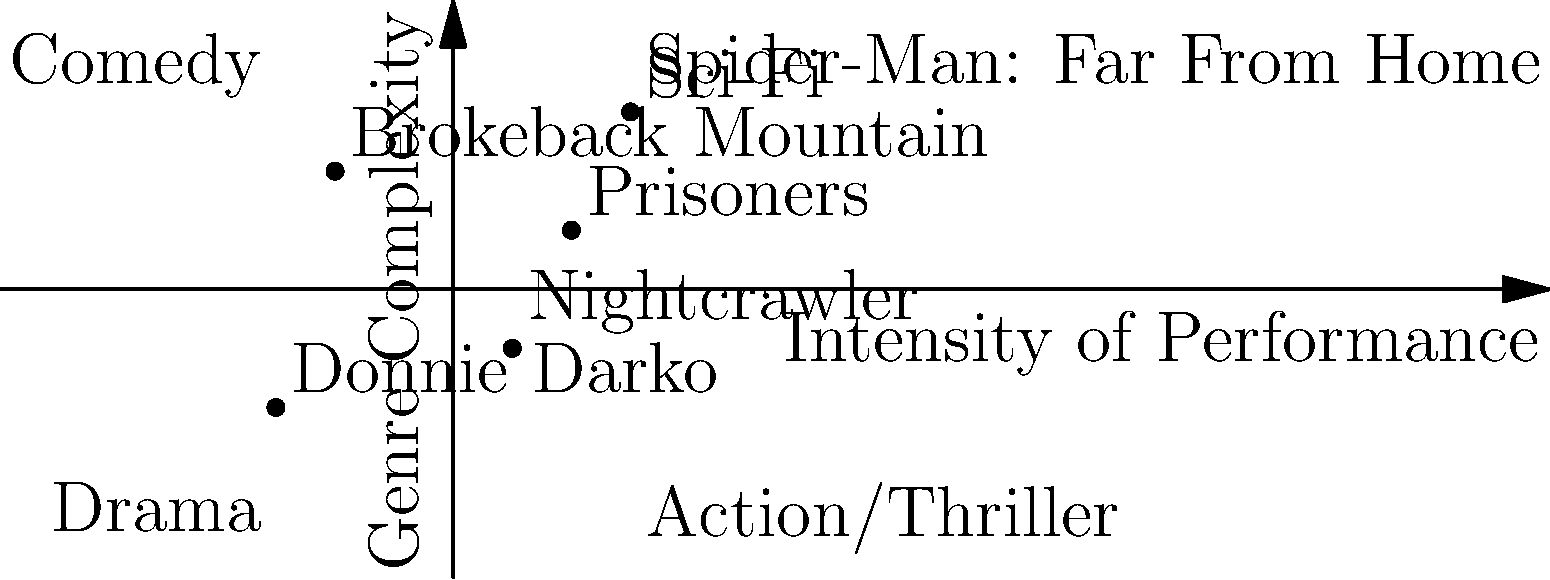In the 2D vector space representing Jake Gyllenhaal's character types, which film represents the highest combination of performance intensity and genre complexity? To determine which film represents the highest combination of performance intensity and genre complexity, we need to analyze the position of each point on the graph:

1. The x-axis represents the intensity of performance, with higher values indicating more intense performances.
2. The y-axis represents genre complexity, with higher values indicating more complex genres.
3. The film that combines the highest values on both axes will be the answer.

Let's examine each point:
1. Donnie Darko: (-3, -2) - Low intensity, low complexity
2. Brokeback Mountain: (-2, 2) - Low intensity, medium-high complexity
3. Nightcrawler: (1, -1) - Medium intensity, low complexity
4. Prisoners: (2, 1) - Medium-high intensity, medium complexity
5. Spider-Man: Far From Home: (3, 3) - High intensity, high complexity

Spider-Man: Far From Home has the highest x-coordinate (3) and the highest y-coordinate (3), indicating the highest combination of performance intensity and genre complexity among the given options.
Answer: Spider-Man: Far From Home 